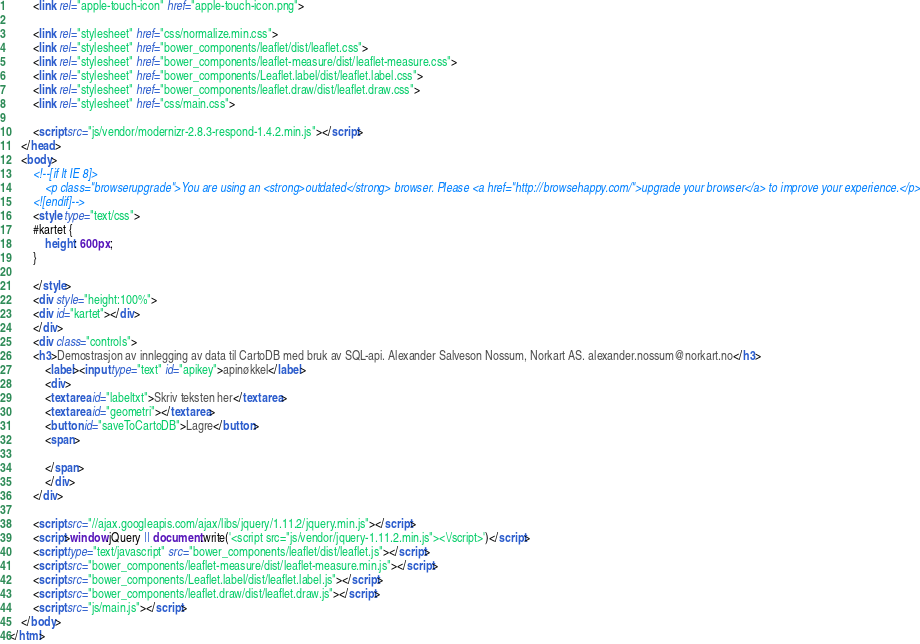<code> <loc_0><loc_0><loc_500><loc_500><_HTML_>        <link rel="apple-touch-icon" href="apple-touch-icon.png">

        <link rel="stylesheet" href="css/normalize.min.css">
        <link rel="stylesheet" href="bower_components/leaflet/dist/leaflet.css">
        <link rel="stylesheet" href="bower_components/leaflet-measure/dist/leaflet-measure.css">
        <link rel="stylesheet" href="bower_components/Leaflet.label/dist/leaflet.label.css">
        <link rel="stylesheet" href="bower_components/leaflet.draw/dist/leaflet.draw.css">
        <link rel="stylesheet" href="css/main.css">

        <script src="js/vendor/modernizr-2.8.3-respond-1.4.2.min.js"></script>
    </head>
    <body>
        <!--[if lt IE 8]>
            <p class="browserupgrade">You are using an <strong>outdated</strong> browser. Please <a href="http://browsehappy.com/">upgrade your browser</a> to improve your experience.</p>
        <![endif]-->
        <style type="text/css">
        #kartet {
            height: 600px;
        }

        </style>
        <div style="height:100%">
        <div id="kartet"></div>
        </div>
        <div class="controls">
        <h3>Demostrasjon av innlegging av data til CartoDB med bruk av SQL-api. Alexander Salveson Nossum, Norkart AS. alexander.nossum@norkart.no</h3>
            <label><input type="text" id="apikey">apinøkkel</label>
            <div>
            <textarea id="labeltxt">Skriv teksten her</textarea>
            <textarea id="geometri"></textarea>
            <button id="saveToCartoDB">Lagre</button>
            <span>
                
            </span>
            </div>
        </div>

        <script src="//ajax.googleapis.com/ajax/libs/jquery/1.11.2/jquery.min.js"></script>
        <script>window.jQuery || document.write('<script src="js/vendor/jquery-1.11.2.min.js"><\/script>')</script>
        <script type="text/javascript" src="bower_components/leaflet/dist/leaflet.js"></script>
        <script src="bower_components/leaflet-measure/dist/leaflet-measure.min.js"></script>
        <script src="bower_components/Leaflet.label/dist/leaflet.label.js"></script>
        <script src="bower_components/leaflet.draw/dist/leaflet.draw.js"></script>
        <script src="js/main.js"></script>
    </body>
</html>
</code> 